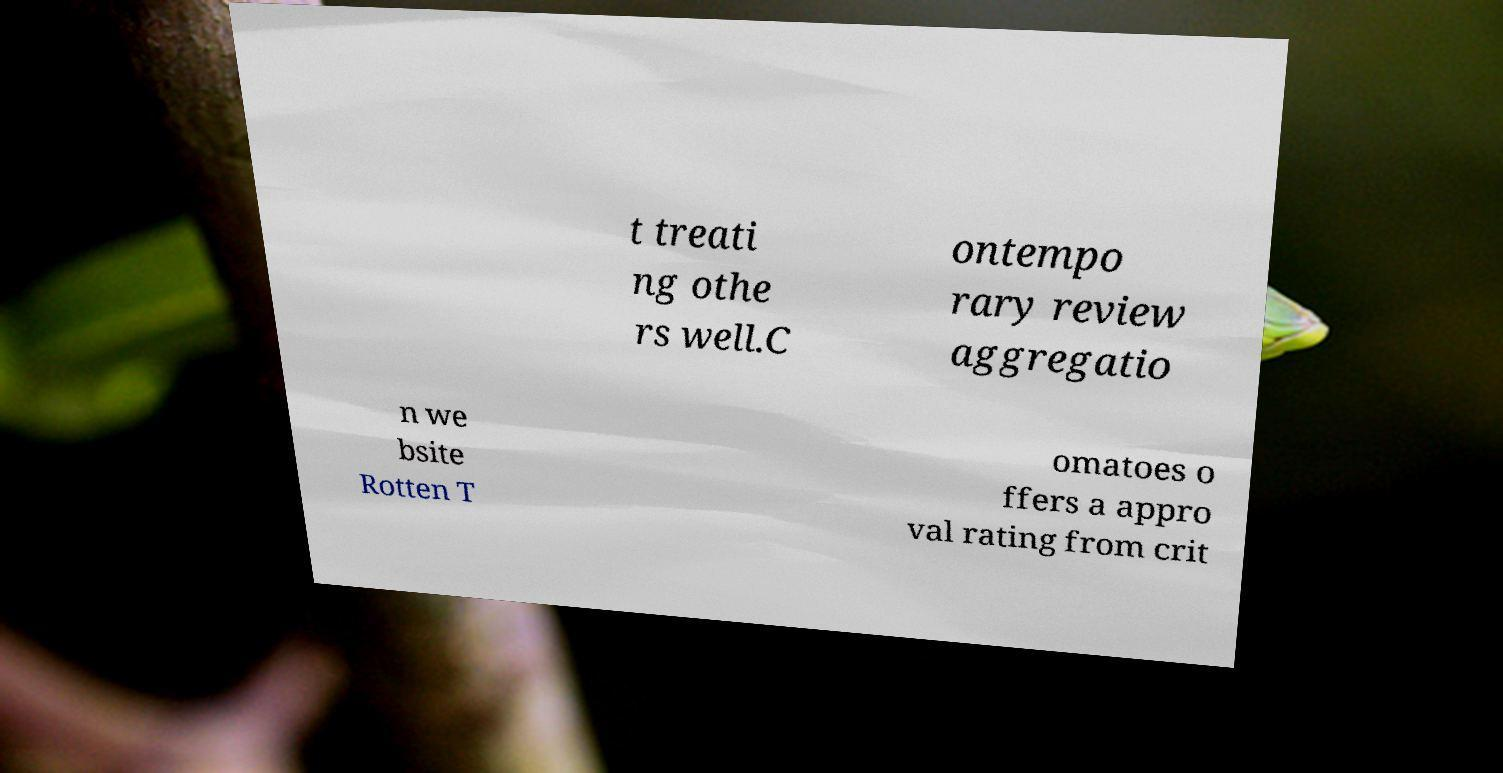Could you assist in decoding the text presented in this image and type it out clearly? t treati ng othe rs well.C ontempo rary review aggregatio n we bsite Rotten T omatoes o ffers a appro val rating from crit 